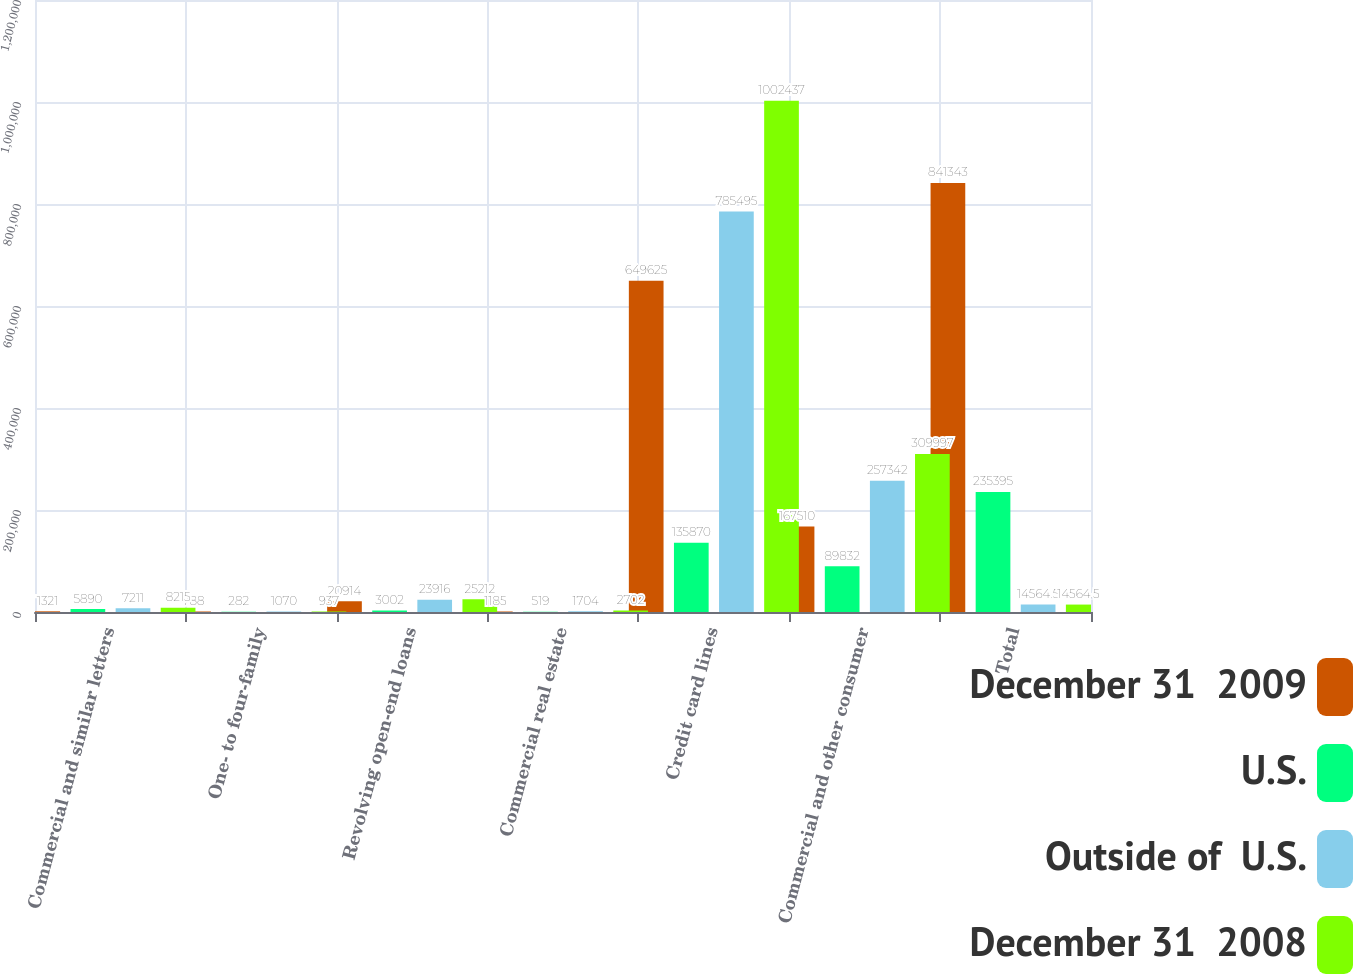Convert chart. <chart><loc_0><loc_0><loc_500><loc_500><stacked_bar_chart><ecel><fcel>Commercial and similar letters<fcel>One- to four-family<fcel>Revolving open-end loans<fcel>Commercial real estate<fcel>Credit card lines<fcel>Commercial and other consumer<fcel>Total<nl><fcel>December 31  2009<fcel>1321<fcel>788<fcel>20914<fcel>1185<fcel>649625<fcel>167510<fcel>841343<nl><fcel>U.S.<fcel>5890<fcel>282<fcel>3002<fcel>519<fcel>135870<fcel>89832<fcel>235395<nl><fcel>Outside of  U.S.<fcel>7211<fcel>1070<fcel>23916<fcel>1704<fcel>785495<fcel>257342<fcel>14564.5<nl><fcel>December 31  2008<fcel>8215<fcel>937<fcel>25212<fcel>2702<fcel>1.00244e+06<fcel>309997<fcel>14564.5<nl></chart> 